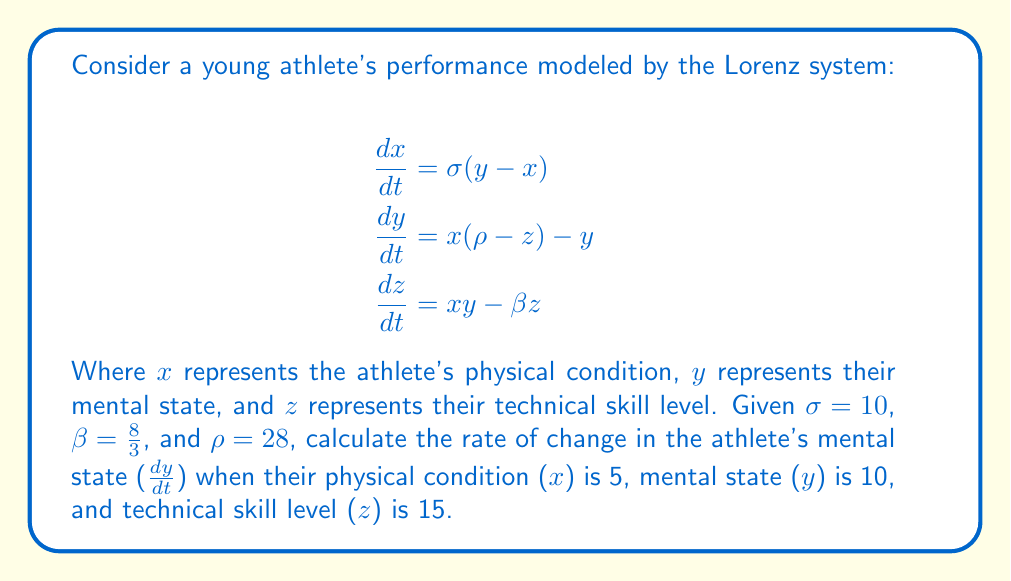Give your solution to this math problem. To solve this problem, we need to follow these steps:

1. Identify the equation for $\frac{dy}{dt}$ in the Lorenz system:
   $$\frac{dy}{dt} = x(\rho-z) - y$$

2. Substitute the given values:
   - $x = 5$
   - $y = 10$
   - $z = 15$
   - $\rho = 28$

3. Calculate $\frac{dy}{dt}$:
   $$\frac{dy}{dt} = 5(28-15) - 10$$
   $$\frac{dy}{dt} = 5(13) - 10$$
   $$\frac{dy}{dt} = 65 - 10$$
   $$\frac{dy}{dt} = 55$$

This result indicates that the athlete's mental state is changing at a rate of 55 units per time step. In the context of the butterfly effect, even small changes in initial conditions can lead to significant differences in outcomes over time. For an athlete, this could mean that minor adjustments in training or preparation could have substantial impacts on performance.
Answer: $55$ 